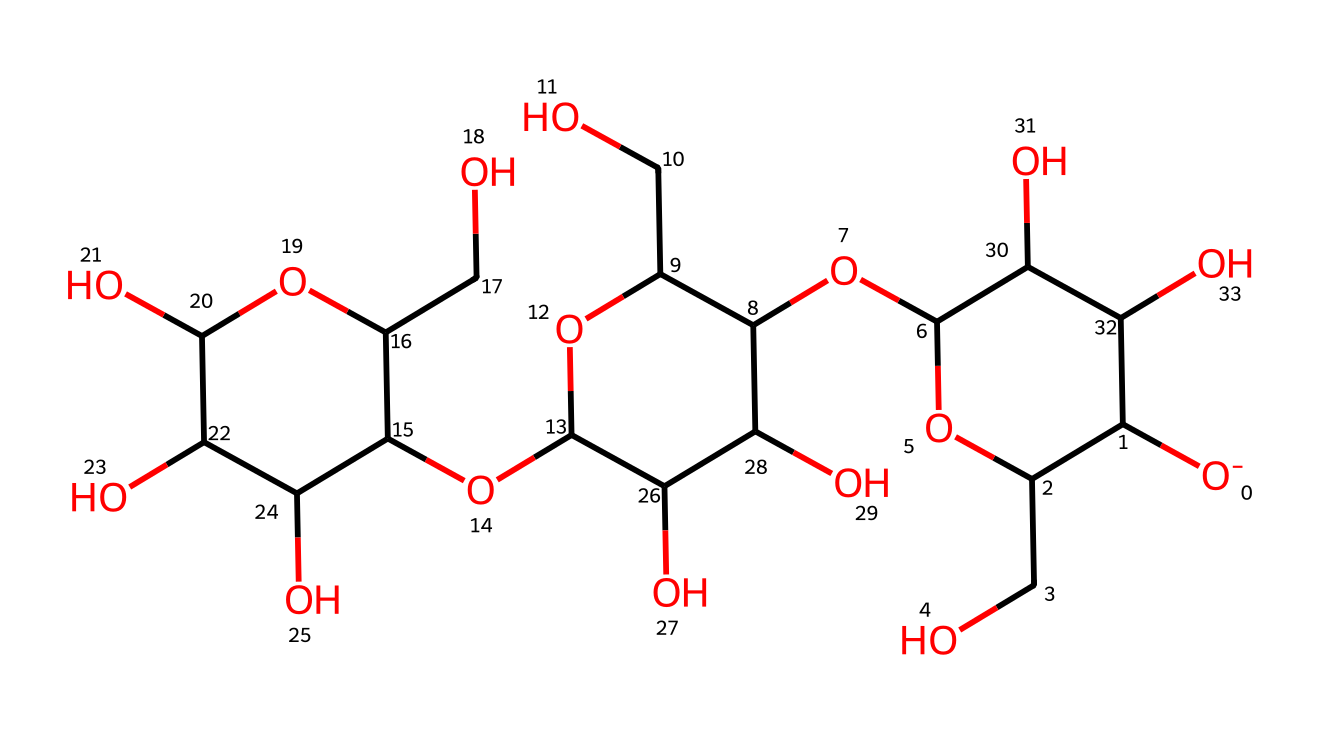What is the main type of chemical this represents? The chemical structure shown is cellulose, a polysaccharide. This conclusion is drawn from the presence of multiple sugar units (monosaccharides) connected by glycosidic bonds, which is characteristic of polysaccharides.
Answer: cellulose How many carbon atoms are in this chemical structure? By examining the SMILES representation and counting the carbon atoms, we find that cellulose contains a total of six carbon atoms in one repeating unit, and since there are multiple units, the total is higher. Counting them gives a total of 18 carbon atoms in this specific structure.
Answer: 18 What functional groups are present in the structure? The structure exhibits several hydroxyl (-OH) functional groups, as indicated by the numerous "O" atoms bonded to hydrogen (H) atoms. These hydroxyl groups are characteristic of alcohols and contribute to the solubility and reactivity of cellulose.
Answer: hydroxyl groups How many oxygen atoms are in the structure? The SMILES representation indicates several oxygen atoms present. By careful examination and counting, it can be determined that there are six oxygen atoms in this chemical structure.
Answer: 6 What type of bonding is primarily involved in linking the monosaccharides in this structure? The monosaccharides are linked by glycosidic bonds, which are formed through dehydration reactions between the hydroxyl groups of adjacent sugar units. This type of bonding is a defining feature of polysaccharides like cellulose.
Answer: glycosidic bonds Is this chemical soluble in water, and why? Yes, cellulose is partially soluble in water due to the many hydroxyl groups that can form hydrogen bonds with water molecules. However, its crystallinity and high molecular weight limit its overall solubility.
Answer: partially soluble What is a primary application of cellulose found in office paper? Cellulose is primarily used in office paper because it provides strength and durability, making it suitable for various types of documents. The fibrous nature of cellulose contributes significantly to the paper's texture and function.
Answer: paper manufacturing 